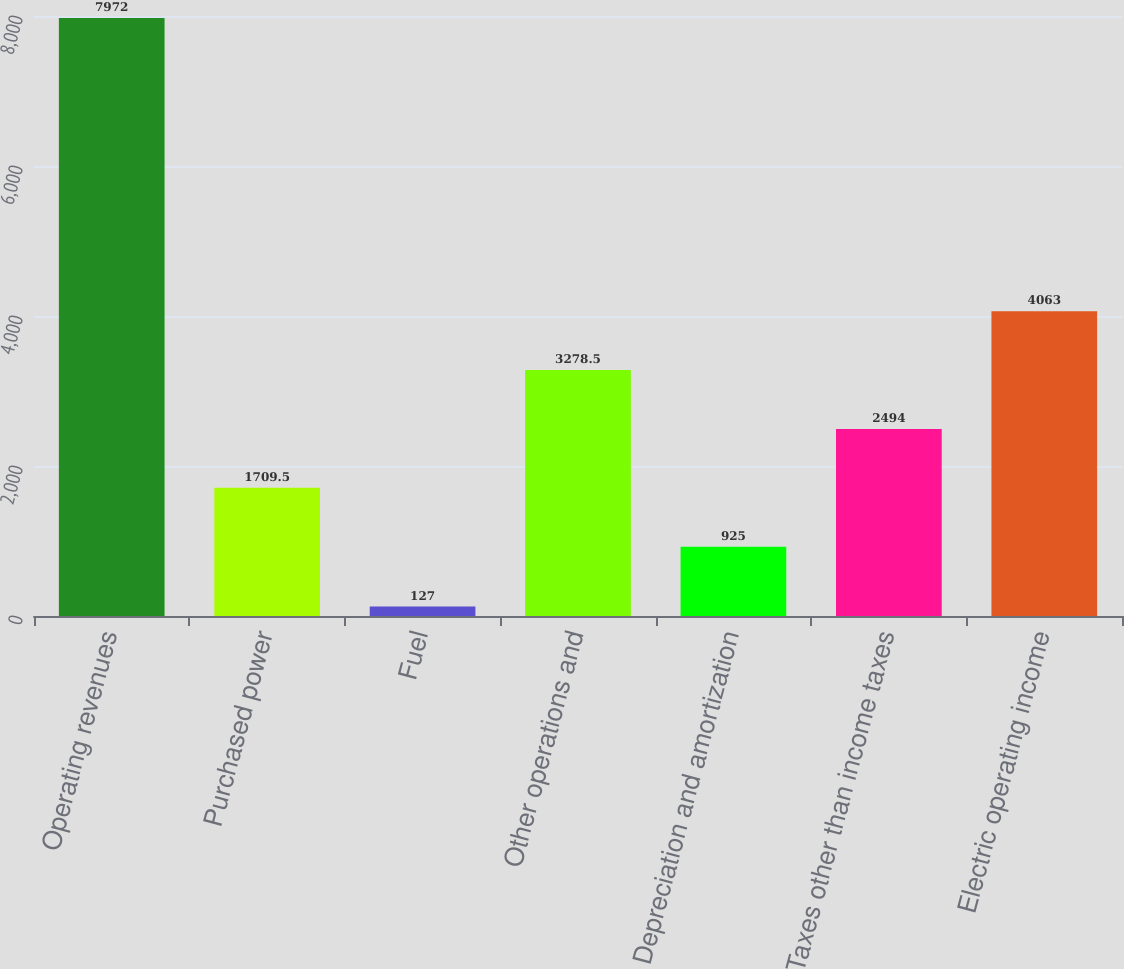Convert chart. <chart><loc_0><loc_0><loc_500><loc_500><bar_chart><fcel>Operating revenues<fcel>Purchased power<fcel>Fuel<fcel>Other operations and<fcel>Depreciation and amortization<fcel>Taxes other than income taxes<fcel>Electric operating income<nl><fcel>7972<fcel>1709.5<fcel>127<fcel>3278.5<fcel>925<fcel>2494<fcel>4063<nl></chart> 